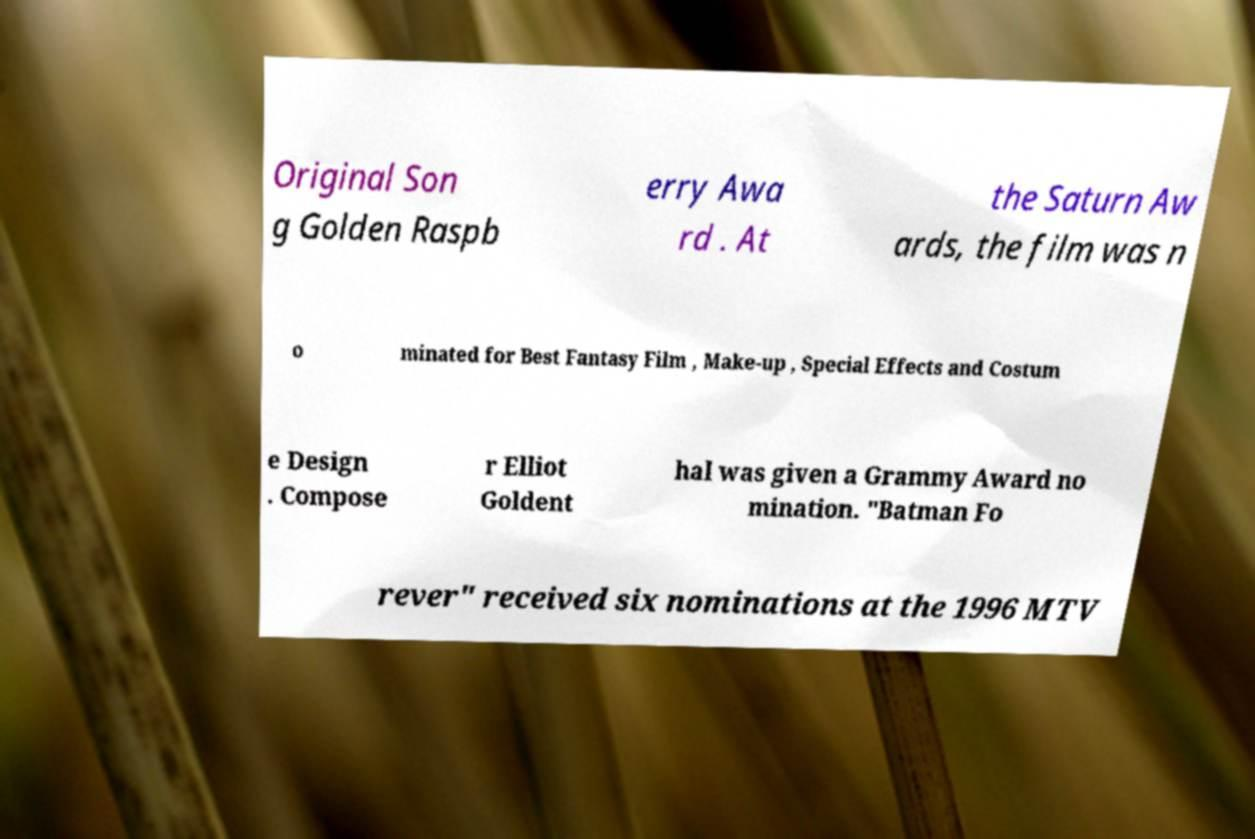Can you accurately transcribe the text from the provided image for me? Original Son g Golden Raspb erry Awa rd . At the Saturn Aw ards, the film was n o minated for Best Fantasy Film , Make-up , Special Effects and Costum e Design . Compose r Elliot Goldent hal was given a Grammy Award no mination. "Batman Fo rever" received six nominations at the 1996 MTV 